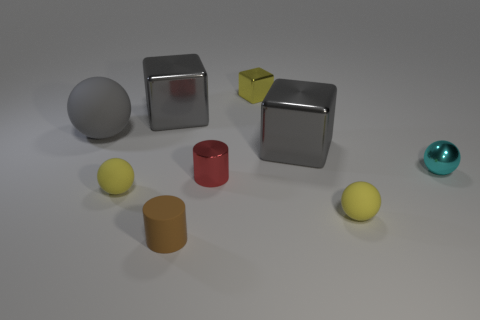Subtract all yellow blocks. Subtract all cyan spheres. How many blocks are left? 2 Add 1 cyan objects. How many objects exist? 10 Subtract all blocks. How many objects are left? 6 Subtract all tiny green metallic objects. Subtract all big balls. How many objects are left? 8 Add 1 gray metal objects. How many gray metal objects are left? 3 Add 4 small red metal cylinders. How many small red metal cylinders exist? 5 Subtract 0 blue blocks. How many objects are left? 9 